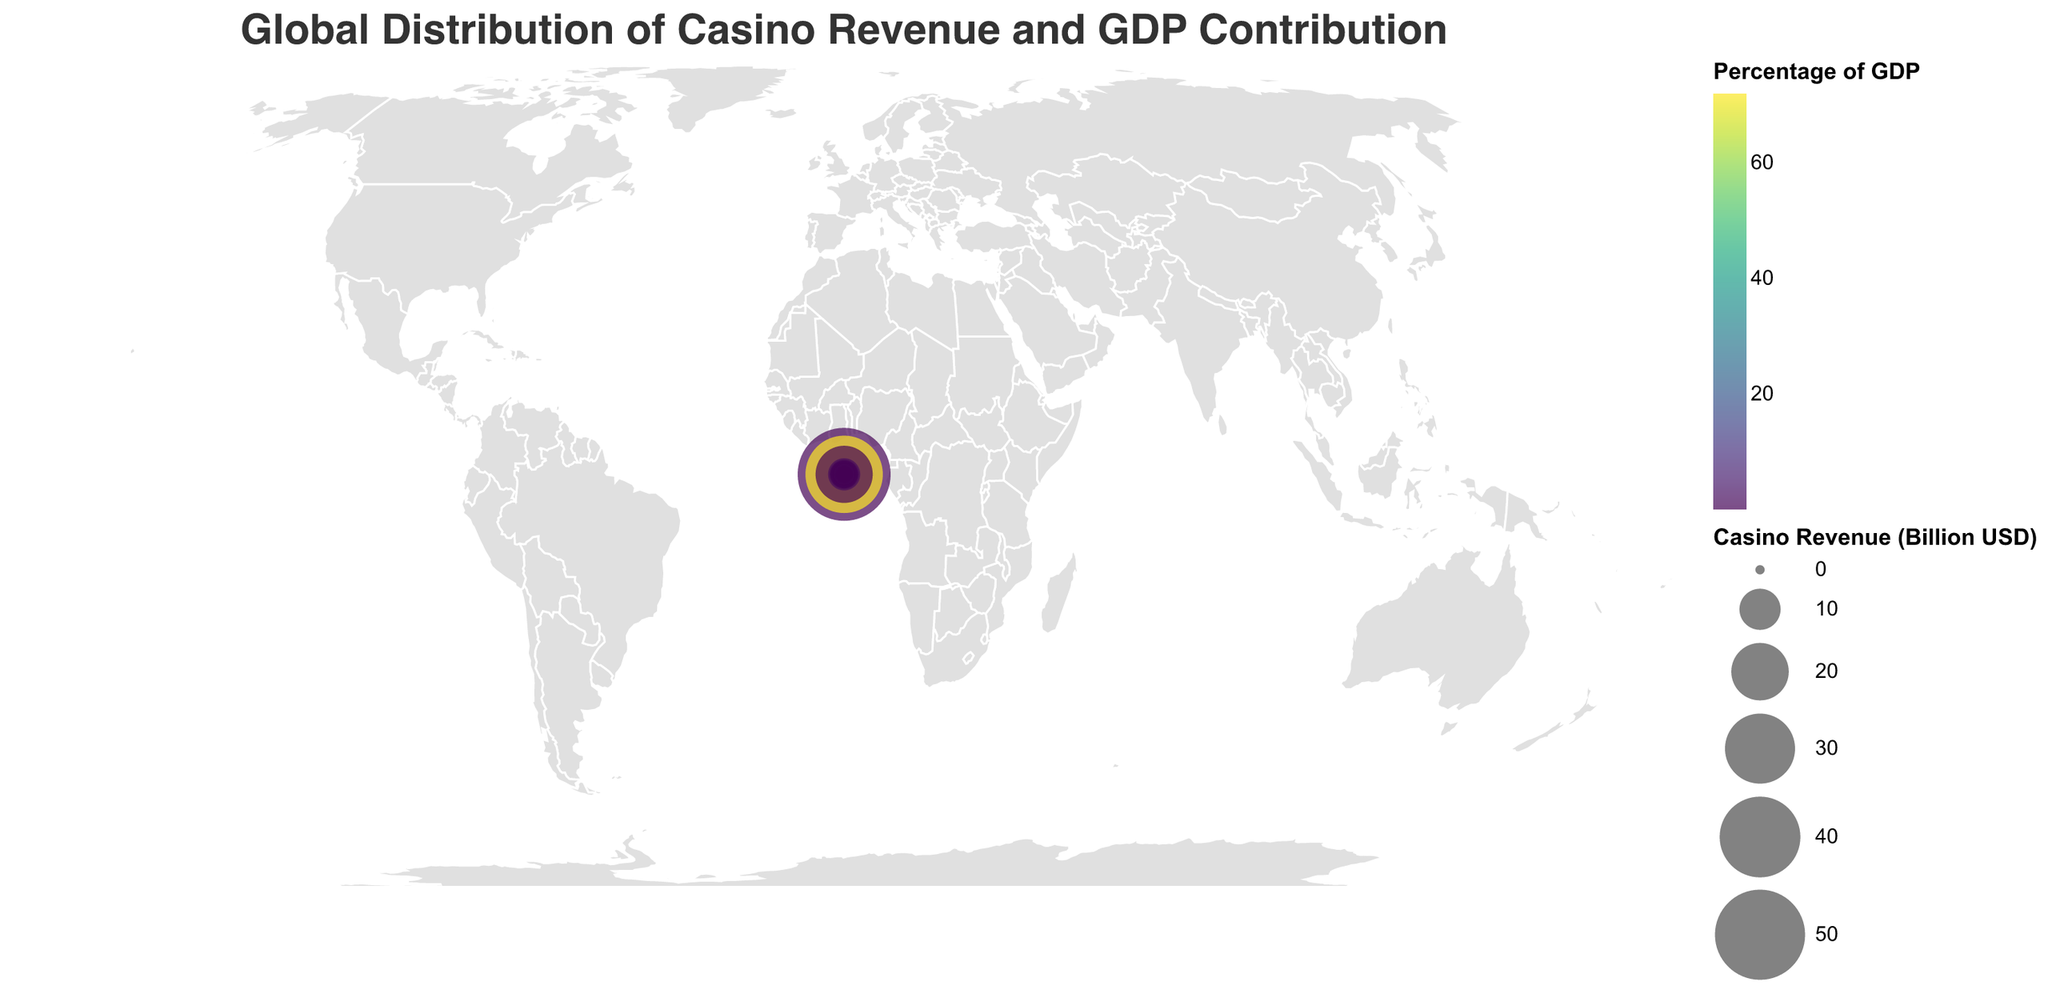How many countries are represented in the figure? Count the number of unique countries listed in the data.
Answer: 15 Which country has the highest casino revenue, and what is that revenue? Identify the country with the maximum value in the "Casino Revenue (Billion USD)" column.
Answer: United States, 53.2 Billion USD Which country has the highest percentage of the GDP coming from casino revenue? Identify the country with the maximum value in the "Percentage of GDP" column.
Answer: Macau, 72.0% What is the sum of casino revenues from Germany and France? Add the casino revenues from Germany and France, i.e., 2.1 + 2.9 = 5.0 Billion USD.
Answer: 5.0 Billion USD Which countries have a casino revenue greater than 10 Billion USD? Identify the countries whose casino revenue values exceed 10 Billion USD.
Answer: United States, Macau, Japan Which country has the smallest percentage of GDP from casino revenue, and what is the value? Identify the country with the minimum value in the "Percentage of GDP" column.
Answer: Germany, 0.05% Compare the casino revenue of Singapore and the United Kingdom. Which one is higher, and by how much? Identify the casino revenues for Singapore and the United Kingdom, then subtract the UK's revenue from Singapore's revenue, i.e., 5.9 - 4.1 = 1.8 Billion USD.
Answer: Singapore is higher by 1.8 Billion USD What is the average percentage of GDP contributed by casino revenue across all countries? Sum all the percentages of GDP and divide by the number of countries, i.e., (0.25 + 72.0 + 0.39 + 1.62 + 0.33 + 0.14 + 0.22 + 0.11 + 0.05 + 0.12 + 0.55 + 0.08 + 0.11 + 0.15 + 0.08) / 15 ≈ 5.20%.
Answer: 5.20% Which country has a casino revenue closest to 2 Billion USD? Identify the countries with casino revenues close to 2 Billion USD and find the closest one.
Answer: South Korea, 2.0 Billion USD Rank the countries by their casino revenue in descending order. Sort the countries based on their casino revenues from highest to lowest.
Answer: United States, Macau, Japan, Singapore, Australia, United Kingdom, Canada, France, Germany, South Korea, Philippines, Italy, Spain, Netherlands, Russia 